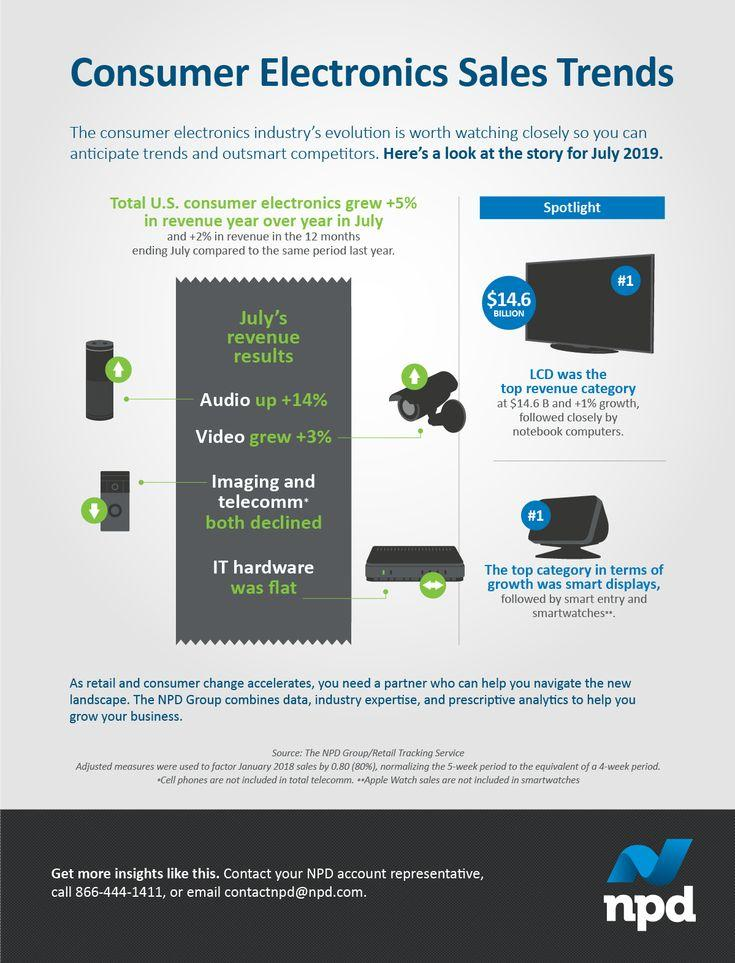Point out several critical features in this image. LCD televisions registered the highest growth among Electronics, Imaging and Telecommunication devices, Notebooks, and LCD televisions in the market. The three most popular categories of smart devices are smart displays, smart entry, and smart watches. 